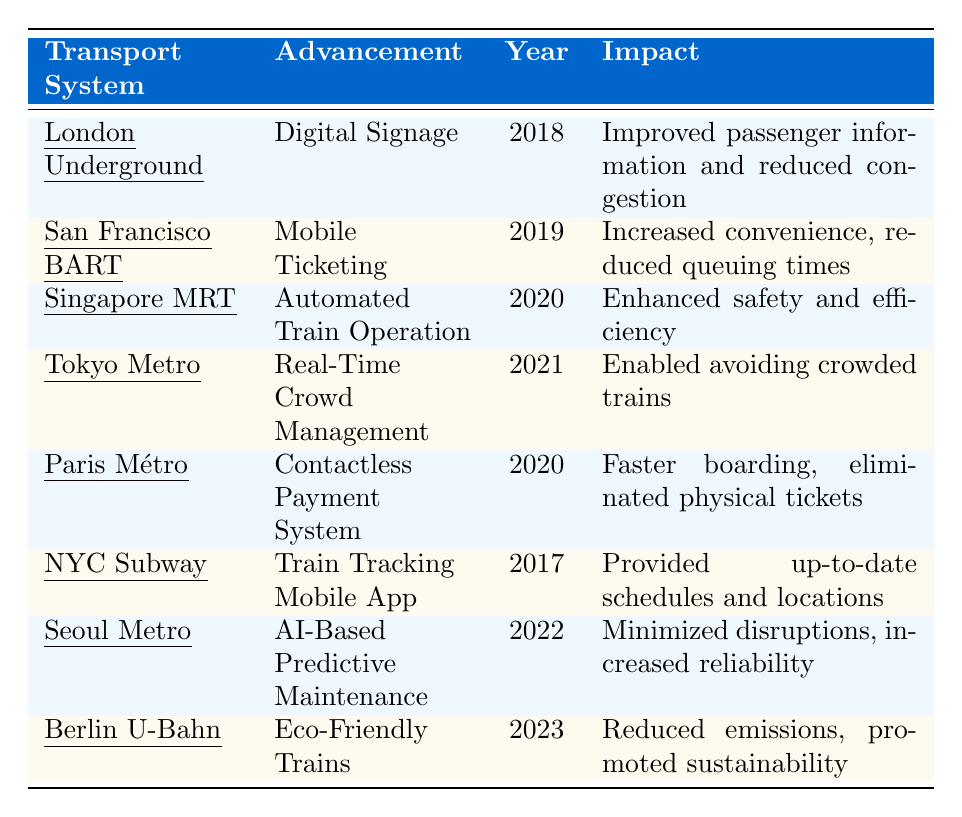What year was the Contactless Payment System implemented in Paris Métro? The table indicates that the Paris Métro implemented the Contactless Payment System in the year 2020.
Answer: 2020 What impact did the Real-Time Crowd Management have on Tokyo Metro? According to the table, the Real-Time Crowd Management enabled riders to avoid crowded trains, improving the overall commuting experience.
Answer: Enabled avoiding crowded trains Which transport system introduced Eco-Friendly Trains in the most recent year? The table shows that Berlin U-Bahn introduced Eco-Friendly Trains in the year 2023, making it the most recent advancement among the listed systems.
Answer: Berlin U-Bahn How many transport systems implemented advancements in the year 2020? By counting the entries for the year 2020, we find that there are two advancements: Automated Train Operation in Singapore MRT and Contactless Payment System in Paris Métro. Thus, the count is 2.
Answer: 2 Did any transport systems implement advancements before 2018? The table shows that all advancements listed were implemented in 2017 or later, with the earliest being the Train Tracking Mobile App in the New York City Subway in 2017. Therefore, the answer is no.
Answer: No Which advancement was implemented by the Seoul Metropolitan Subway, and what was its impact? The table reveals that the Seoul Metropolitan Subway implemented AI-Based Predictive Maintenance, which minimized service disruptions and increased the reliability of train operations.
Answer: AI-Based Predictive Maintenance; minimized disruptions, increased reliability What is the combined number of advancements introduced by London Underground and New York City Subway? The table shows two systems: London Underground introduced Digital Signage, and New York City Subway introduced a Train Tracking Mobile App. Therefore, the total number of advancements is 2.
Answer: 2 Could you identify if the impact of Mobile Ticketing in BART relates more to convenience or efficiency? The table indicates that Mobile Ticketing in BART increased convenience for travelers and reduced queuing times, suggesting it relates more to convenience.
Answer: Convenience Which advancement has the most environmental impact based on the data? The Eco-Friendly Trains in Berlin U-Bahn, introduced in 2023, specifically mentions reduced emissions and promotes sustainability, indicating it has the most environmental impact.
Answer: Eco-Friendly Trains How does the implementation year of the Digital Signage in London Underground compare to the AI-Based Predictive Maintenance in Seoul Metropolitan Subway? The table shows that Digital Signage in London Underground was implemented in 2018, while AI-Based Predictive Maintenance in Seoul Metropolitan Subway was implemented in 2022. Comparing these years reveals that AI-Based Predictive Maintenance was implemented 4 years later than Digital Signage.
Answer: 4 years later 